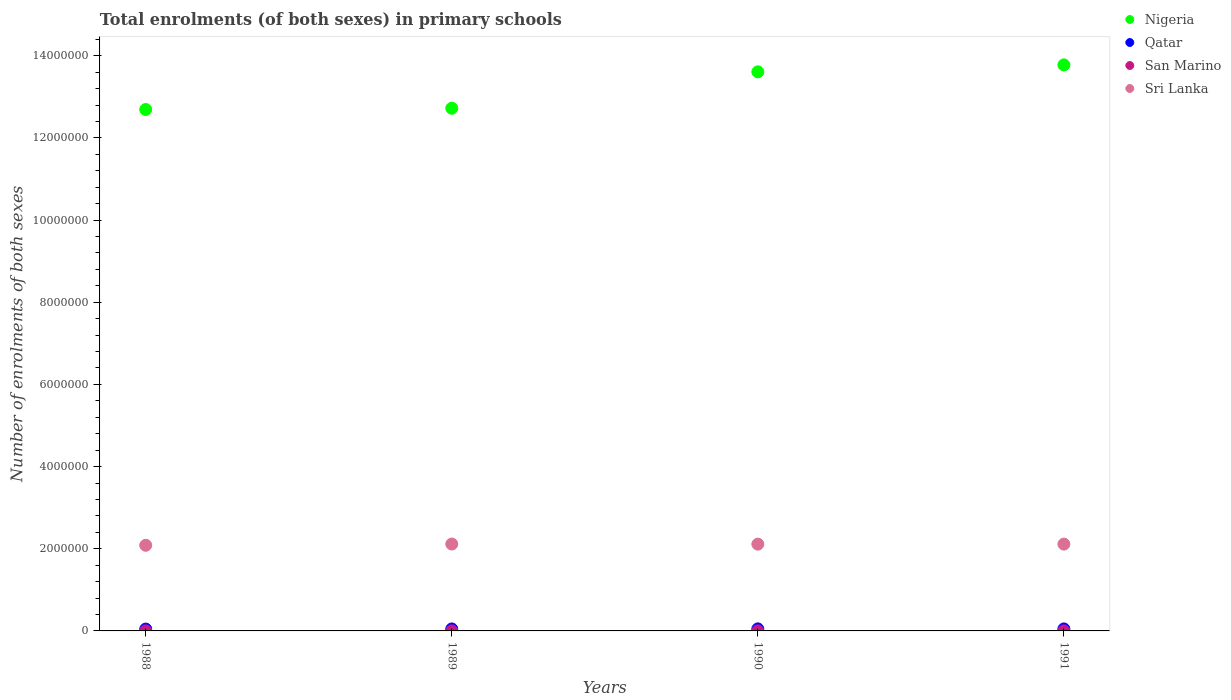How many different coloured dotlines are there?
Your answer should be very brief. 4. Is the number of dotlines equal to the number of legend labels?
Give a very brief answer. Yes. What is the number of enrolments in primary schools in Nigeria in 1988?
Offer a very short reply. 1.27e+07. Across all years, what is the maximum number of enrolments in primary schools in San Marino?
Your response must be concise. 1288. Across all years, what is the minimum number of enrolments in primary schools in Qatar?
Your answer should be very brief. 4.54e+04. What is the total number of enrolments in primary schools in Sri Lanka in the graph?
Make the answer very short. 8.42e+06. What is the difference between the number of enrolments in primary schools in Sri Lanka in 1989 and that in 1990?
Give a very brief answer. 2777. What is the difference between the number of enrolments in primary schools in Qatar in 1991 and the number of enrolments in primary schools in Sri Lanka in 1989?
Your answer should be very brief. -2.07e+06. What is the average number of enrolments in primary schools in Sri Lanka per year?
Give a very brief answer. 2.11e+06. In the year 1989, what is the difference between the number of enrolments in primary schools in Qatar and number of enrolments in primary schools in Sri Lanka?
Give a very brief answer. -2.07e+06. In how many years, is the number of enrolments in primary schools in Sri Lanka greater than 4400000?
Offer a very short reply. 0. What is the ratio of the number of enrolments in primary schools in Qatar in 1989 to that in 1990?
Provide a succinct answer. 0.97. Is the difference between the number of enrolments in primary schools in Qatar in 1988 and 1989 greater than the difference between the number of enrolments in primary schools in Sri Lanka in 1988 and 1989?
Keep it short and to the point. Yes. What is the difference between the highest and the second highest number of enrolments in primary schools in Nigeria?
Offer a terse response. 1.70e+05. What is the difference between the highest and the lowest number of enrolments in primary schools in Nigeria?
Your answer should be very brief. 1.09e+06. Is it the case that in every year, the sum of the number of enrolments in primary schools in Nigeria and number of enrolments in primary schools in Qatar  is greater than the number of enrolments in primary schools in Sri Lanka?
Your answer should be compact. Yes. Is the number of enrolments in primary schools in Nigeria strictly less than the number of enrolments in primary schools in San Marino over the years?
Your answer should be very brief. No. How many dotlines are there?
Your answer should be compact. 4. Does the graph contain grids?
Your answer should be compact. No. What is the title of the graph?
Keep it short and to the point. Total enrolments (of both sexes) in primary schools. Does "Moldova" appear as one of the legend labels in the graph?
Your response must be concise. No. What is the label or title of the X-axis?
Ensure brevity in your answer.  Years. What is the label or title of the Y-axis?
Provide a short and direct response. Number of enrolments of both sexes. What is the Number of enrolments of both sexes in Nigeria in 1988?
Give a very brief answer. 1.27e+07. What is the Number of enrolments of both sexes in Qatar in 1988?
Ensure brevity in your answer.  4.54e+04. What is the Number of enrolments of both sexes of San Marino in 1988?
Ensure brevity in your answer.  1288. What is the Number of enrolments of both sexes of Sri Lanka in 1988?
Your answer should be compact. 2.08e+06. What is the Number of enrolments of both sexes of Nigeria in 1989?
Ensure brevity in your answer.  1.27e+07. What is the Number of enrolments of both sexes in Qatar in 1989?
Ensure brevity in your answer.  4.81e+04. What is the Number of enrolments of both sexes in San Marino in 1989?
Ensure brevity in your answer.  1266. What is the Number of enrolments of both sexes in Sri Lanka in 1989?
Provide a succinct answer. 2.11e+06. What is the Number of enrolments of both sexes in Nigeria in 1990?
Ensure brevity in your answer.  1.36e+07. What is the Number of enrolments of both sexes of Qatar in 1990?
Your response must be concise. 4.97e+04. What is the Number of enrolments of both sexes of San Marino in 1990?
Offer a very short reply. 1227. What is the Number of enrolments of both sexes in Sri Lanka in 1990?
Your answer should be very brief. 2.11e+06. What is the Number of enrolments of both sexes in Nigeria in 1991?
Your response must be concise. 1.38e+07. What is the Number of enrolments of both sexes in Qatar in 1991?
Provide a short and direct response. 4.86e+04. What is the Number of enrolments of both sexes in San Marino in 1991?
Keep it short and to the point. 1212. What is the Number of enrolments of both sexes of Sri Lanka in 1991?
Ensure brevity in your answer.  2.11e+06. Across all years, what is the maximum Number of enrolments of both sexes of Nigeria?
Give a very brief answer. 1.38e+07. Across all years, what is the maximum Number of enrolments of both sexes in Qatar?
Give a very brief answer. 4.97e+04. Across all years, what is the maximum Number of enrolments of both sexes of San Marino?
Make the answer very short. 1288. Across all years, what is the maximum Number of enrolments of both sexes in Sri Lanka?
Ensure brevity in your answer.  2.11e+06. Across all years, what is the minimum Number of enrolments of both sexes of Nigeria?
Offer a very short reply. 1.27e+07. Across all years, what is the minimum Number of enrolments of both sexes in Qatar?
Provide a short and direct response. 4.54e+04. Across all years, what is the minimum Number of enrolments of both sexes in San Marino?
Offer a terse response. 1212. Across all years, what is the minimum Number of enrolments of both sexes in Sri Lanka?
Your answer should be compact. 2.08e+06. What is the total Number of enrolments of both sexes of Nigeria in the graph?
Offer a terse response. 5.28e+07. What is the total Number of enrolments of both sexes of Qatar in the graph?
Make the answer very short. 1.92e+05. What is the total Number of enrolments of both sexes in San Marino in the graph?
Make the answer very short. 4993. What is the total Number of enrolments of both sexes of Sri Lanka in the graph?
Offer a terse response. 8.42e+06. What is the difference between the Number of enrolments of both sexes in Nigeria in 1988 and that in 1989?
Make the answer very short. -3.03e+04. What is the difference between the Number of enrolments of both sexes of Qatar in 1988 and that in 1989?
Ensure brevity in your answer.  -2730. What is the difference between the Number of enrolments of both sexes of San Marino in 1988 and that in 1989?
Keep it short and to the point. 22. What is the difference between the Number of enrolments of both sexes of Sri Lanka in 1988 and that in 1989?
Your answer should be compact. -3.08e+04. What is the difference between the Number of enrolments of both sexes of Nigeria in 1988 and that in 1990?
Provide a succinct answer. -9.16e+05. What is the difference between the Number of enrolments of both sexes in Qatar in 1988 and that in 1990?
Your answer should be very brief. -4290. What is the difference between the Number of enrolments of both sexes of San Marino in 1988 and that in 1990?
Keep it short and to the point. 61. What is the difference between the Number of enrolments of both sexes in Sri Lanka in 1988 and that in 1990?
Your answer should be compact. -2.80e+04. What is the difference between the Number of enrolments of both sexes of Nigeria in 1988 and that in 1991?
Make the answer very short. -1.09e+06. What is the difference between the Number of enrolments of both sexes in Qatar in 1988 and that in 1991?
Offer a very short reply. -3283. What is the difference between the Number of enrolments of both sexes in Sri Lanka in 1988 and that in 1991?
Your response must be concise. -2.87e+04. What is the difference between the Number of enrolments of both sexes in Nigeria in 1989 and that in 1990?
Provide a succinct answer. -8.86e+05. What is the difference between the Number of enrolments of both sexes of Qatar in 1989 and that in 1990?
Offer a terse response. -1560. What is the difference between the Number of enrolments of both sexes in Sri Lanka in 1989 and that in 1990?
Your response must be concise. 2777. What is the difference between the Number of enrolments of both sexes in Nigeria in 1989 and that in 1991?
Provide a short and direct response. -1.06e+06. What is the difference between the Number of enrolments of both sexes in Qatar in 1989 and that in 1991?
Ensure brevity in your answer.  -553. What is the difference between the Number of enrolments of both sexes in Sri Lanka in 1989 and that in 1991?
Your answer should be compact. 2077. What is the difference between the Number of enrolments of both sexes of Nigeria in 1990 and that in 1991?
Provide a short and direct response. -1.70e+05. What is the difference between the Number of enrolments of both sexes in Qatar in 1990 and that in 1991?
Provide a short and direct response. 1007. What is the difference between the Number of enrolments of both sexes of San Marino in 1990 and that in 1991?
Provide a short and direct response. 15. What is the difference between the Number of enrolments of both sexes of Sri Lanka in 1990 and that in 1991?
Your answer should be compact. -700. What is the difference between the Number of enrolments of both sexes of Nigeria in 1988 and the Number of enrolments of both sexes of Qatar in 1989?
Give a very brief answer. 1.26e+07. What is the difference between the Number of enrolments of both sexes in Nigeria in 1988 and the Number of enrolments of both sexes in San Marino in 1989?
Give a very brief answer. 1.27e+07. What is the difference between the Number of enrolments of both sexes of Nigeria in 1988 and the Number of enrolments of both sexes of Sri Lanka in 1989?
Your answer should be compact. 1.06e+07. What is the difference between the Number of enrolments of both sexes of Qatar in 1988 and the Number of enrolments of both sexes of San Marino in 1989?
Provide a short and direct response. 4.41e+04. What is the difference between the Number of enrolments of both sexes of Qatar in 1988 and the Number of enrolments of both sexes of Sri Lanka in 1989?
Ensure brevity in your answer.  -2.07e+06. What is the difference between the Number of enrolments of both sexes of San Marino in 1988 and the Number of enrolments of both sexes of Sri Lanka in 1989?
Make the answer very short. -2.11e+06. What is the difference between the Number of enrolments of both sexes of Nigeria in 1988 and the Number of enrolments of both sexes of Qatar in 1990?
Your response must be concise. 1.26e+07. What is the difference between the Number of enrolments of both sexes of Nigeria in 1988 and the Number of enrolments of both sexes of San Marino in 1990?
Ensure brevity in your answer.  1.27e+07. What is the difference between the Number of enrolments of both sexes of Nigeria in 1988 and the Number of enrolments of both sexes of Sri Lanka in 1990?
Your answer should be compact. 1.06e+07. What is the difference between the Number of enrolments of both sexes in Qatar in 1988 and the Number of enrolments of both sexes in San Marino in 1990?
Ensure brevity in your answer.  4.41e+04. What is the difference between the Number of enrolments of both sexes of Qatar in 1988 and the Number of enrolments of both sexes of Sri Lanka in 1990?
Your answer should be very brief. -2.07e+06. What is the difference between the Number of enrolments of both sexes of San Marino in 1988 and the Number of enrolments of both sexes of Sri Lanka in 1990?
Provide a short and direct response. -2.11e+06. What is the difference between the Number of enrolments of both sexes in Nigeria in 1988 and the Number of enrolments of both sexes in Qatar in 1991?
Make the answer very short. 1.26e+07. What is the difference between the Number of enrolments of both sexes in Nigeria in 1988 and the Number of enrolments of both sexes in San Marino in 1991?
Offer a very short reply. 1.27e+07. What is the difference between the Number of enrolments of both sexes of Nigeria in 1988 and the Number of enrolments of both sexes of Sri Lanka in 1991?
Offer a very short reply. 1.06e+07. What is the difference between the Number of enrolments of both sexes in Qatar in 1988 and the Number of enrolments of both sexes in San Marino in 1991?
Provide a short and direct response. 4.42e+04. What is the difference between the Number of enrolments of both sexes of Qatar in 1988 and the Number of enrolments of both sexes of Sri Lanka in 1991?
Give a very brief answer. -2.07e+06. What is the difference between the Number of enrolments of both sexes in San Marino in 1988 and the Number of enrolments of both sexes in Sri Lanka in 1991?
Provide a succinct answer. -2.11e+06. What is the difference between the Number of enrolments of both sexes in Nigeria in 1989 and the Number of enrolments of both sexes in Qatar in 1990?
Provide a succinct answer. 1.27e+07. What is the difference between the Number of enrolments of both sexes of Nigeria in 1989 and the Number of enrolments of both sexes of San Marino in 1990?
Your answer should be compact. 1.27e+07. What is the difference between the Number of enrolments of both sexes of Nigeria in 1989 and the Number of enrolments of both sexes of Sri Lanka in 1990?
Your answer should be compact. 1.06e+07. What is the difference between the Number of enrolments of both sexes in Qatar in 1989 and the Number of enrolments of both sexes in San Marino in 1990?
Give a very brief answer. 4.69e+04. What is the difference between the Number of enrolments of both sexes of Qatar in 1989 and the Number of enrolments of both sexes of Sri Lanka in 1990?
Your response must be concise. -2.06e+06. What is the difference between the Number of enrolments of both sexes of San Marino in 1989 and the Number of enrolments of both sexes of Sri Lanka in 1990?
Provide a short and direct response. -2.11e+06. What is the difference between the Number of enrolments of both sexes in Nigeria in 1989 and the Number of enrolments of both sexes in Qatar in 1991?
Offer a very short reply. 1.27e+07. What is the difference between the Number of enrolments of both sexes of Nigeria in 1989 and the Number of enrolments of both sexes of San Marino in 1991?
Make the answer very short. 1.27e+07. What is the difference between the Number of enrolments of both sexes in Nigeria in 1989 and the Number of enrolments of both sexes in Sri Lanka in 1991?
Provide a short and direct response. 1.06e+07. What is the difference between the Number of enrolments of both sexes in Qatar in 1989 and the Number of enrolments of both sexes in San Marino in 1991?
Provide a short and direct response. 4.69e+04. What is the difference between the Number of enrolments of both sexes in Qatar in 1989 and the Number of enrolments of both sexes in Sri Lanka in 1991?
Provide a short and direct response. -2.06e+06. What is the difference between the Number of enrolments of both sexes in San Marino in 1989 and the Number of enrolments of both sexes in Sri Lanka in 1991?
Provide a short and direct response. -2.11e+06. What is the difference between the Number of enrolments of both sexes of Nigeria in 1990 and the Number of enrolments of both sexes of Qatar in 1991?
Ensure brevity in your answer.  1.36e+07. What is the difference between the Number of enrolments of both sexes of Nigeria in 1990 and the Number of enrolments of both sexes of San Marino in 1991?
Offer a terse response. 1.36e+07. What is the difference between the Number of enrolments of both sexes in Nigeria in 1990 and the Number of enrolments of both sexes in Sri Lanka in 1991?
Provide a succinct answer. 1.15e+07. What is the difference between the Number of enrolments of both sexes of Qatar in 1990 and the Number of enrolments of both sexes of San Marino in 1991?
Your answer should be compact. 4.84e+04. What is the difference between the Number of enrolments of both sexes of Qatar in 1990 and the Number of enrolments of both sexes of Sri Lanka in 1991?
Offer a very short reply. -2.06e+06. What is the difference between the Number of enrolments of both sexes of San Marino in 1990 and the Number of enrolments of both sexes of Sri Lanka in 1991?
Provide a succinct answer. -2.11e+06. What is the average Number of enrolments of both sexes in Nigeria per year?
Your answer should be very brief. 1.32e+07. What is the average Number of enrolments of both sexes in Qatar per year?
Make the answer very short. 4.79e+04. What is the average Number of enrolments of both sexes of San Marino per year?
Your answer should be very brief. 1248.25. What is the average Number of enrolments of both sexes of Sri Lanka per year?
Provide a succinct answer. 2.11e+06. In the year 1988, what is the difference between the Number of enrolments of both sexes in Nigeria and Number of enrolments of both sexes in Qatar?
Your answer should be very brief. 1.26e+07. In the year 1988, what is the difference between the Number of enrolments of both sexes of Nigeria and Number of enrolments of both sexes of San Marino?
Make the answer very short. 1.27e+07. In the year 1988, what is the difference between the Number of enrolments of both sexes in Nigeria and Number of enrolments of both sexes in Sri Lanka?
Offer a very short reply. 1.06e+07. In the year 1988, what is the difference between the Number of enrolments of both sexes of Qatar and Number of enrolments of both sexes of San Marino?
Keep it short and to the point. 4.41e+04. In the year 1988, what is the difference between the Number of enrolments of both sexes of Qatar and Number of enrolments of both sexes of Sri Lanka?
Offer a very short reply. -2.04e+06. In the year 1988, what is the difference between the Number of enrolments of both sexes of San Marino and Number of enrolments of both sexes of Sri Lanka?
Your response must be concise. -2.08e+06. In the year 1989, what is the difference between the Number of enrolments of both sexes in Nigeria and Number of enrolments of both sexes in Qatar?
Offer a terse response. 1.27e+07. In the year 1989, what is the difference between the Number of enrolments of both sexes in Nigeria and Number of enrolments of both sexes in San Marino?
Ensure brevity in your answer.  1.27e+07. In the year 1989, what is the difference between the Number of enrolments of both sexes in Nigeria and Number of enrolments of both sexes in Sri Lanka?
Keep it short and to the point. 1.06e+07. In the year 1989, what is the difference between the Number of enrolments of both sexes in Qatar and Number of enrolments of both sexes in San Marino?
Give a very brief answer. 4.68e+04. In the year 1989, what is the difference between the Number of enrolments of both sexes in Qatar and Number of enrolments of both sexes in Sri Lanka?
Make the answer very short. -2.07e+06. In the year 1989, what is the difference between the Number of enrolments of both sexes of San Marino and Number of enrolments of both sexes of Sri Lanka?
Your response must be concise. -2.11e+06. In the year 1990, what is the difference between the Number of enrolments of both sexes of Nigeria and Number of enrolments of both sexes of Qatar?
Your response must be concise. 1.36e+07. In the year 1990, what is the difference between the Number of enrolments of both sexes in Nigeria and Number of enrolments of both sexes in San Marino?
Your answer should be very brief. 1.36e+07. In the year 1990, what is the difference between the Number of enrolments of both sexes of Nigeria and Number of enrolments of both sexes of Sri Lanka?
Your answer should be very brief. 1.15e+07. In the year 1990, what is the difference between the Number of enrolments of both sexes in Qatar and Number of enrolments of both sexes in San Marino?
Your response must be concise. 4.84e+04. In the year 1990, what is the difference between the Number of enrolments of both sexes in Qatar and Number of enrolments of both sexes in Sri Lanka?
Your answer should be very brief. -2.06e+06. In the year 1990, what is the difference between the Number of enrolments of both sexes of San Marino and Number of enrolments of both sexes of Sri Lanka?
Offer a terse response. -2.11e+06. In the year 1991, what is the difference between the Number of enrolments of both sexes of Nigeria and Number of enrolments of both sexes of Qatar?
Offer a very short reply. 1.37e+07. In the year 1991, what is the difference between the Number of enrolments of both sexes in Nigeria and Number of enrolments of both sexes in San Marino?
Provide a succinct answer. 1.38e+07. In the year 1991, what is the difference between the Number of enrolments of both sexes in Nigeria and Number of enrolments of both sexes in Sri Lanka?
Offer a very short reply. 1.17e+07. In the year 1991, what is the difference between the Number of enrolments of both sexes in Qatar and Number of enrolments of both sexes in San Marino?
Your response must be concise. 4.74e+04. In the year 1991, what is the difference between the Number of enrolments of both sexes in Qatar and Number of enrolments of both sexes in Sri Lanka?
Provide a short and direct response. -2.06e+06. In the year 1991, what is the difference between the Number of enrolments of both sexes of San Marino and Number of enrolments of both sexes of Sri Lanka?
Your response must be concise. -2.11e+06. What is the ratio of the Number of enrolments of both sexes of Qatar in 1988 to that in 1989?
Your answer should be very brief. 0.94. What is the ratio of the Number of enrolments of both sexes of San Marino in 1988 to that in 1989?
Your answer should be compact. 1.02. What is the ratio of the Number of enrolments of both sexes in Sri Lanka in 1988 to that in 1989?
Your answer should be very brief. 0.99. What is the ratio of the Number of enrolments of both sexes in Nigeria in 1988 to that in 1990?
Ensure brevity in your answer.  0.93. What is the ratio of the Number of enrolments of both sexes in Qatar in 1988 to that in 1990?
Provide a short and direct response. 0.91. What is the ratio of the Number of enrolments of both sexes of San Marino in 1988 to that in 1990?
Keep it short and to the point. 1.05. What is the ratio of the Number of enrolments of both sexes of Sri Lanka in 1988 to that in 1990?
Provide a short and direct response. 0.99. What is the ratio of the Number of enrolments of both sexes of Nigeria in 1988 to that in 1991?
Your response must be concise. 0.92. What is the ratio of the Number of enrolments of both sexes in Qatar in 1988 to that in 1991?
Make the answer very short. 0.93. What is the ratio of the Number of enrolments of both sexes in San Marino in 1988 to that in 1991?
Your answer should be very brief. 1.06. What is the ratio of the Number of enrolments of both sexes in Sri Lanka in 1988 to that in 1991?
Your answer should be very brief. 0.99. What is the ratio of the Number of enrolments of both sexes in Nigeria in 1989 to that in 1990?
Make the answer very short. 0.93. What is the ratio of the Number of enrolments of both sexes of Qatar in 1989 to that in 1990?
Your answer should be very brief. 0.97. What is the ratio of the Number of enrolments of both sexes in San Marino in 1989 to that in 1990?
Your answer should be compact. 1.03. What is the ratio of the Number of enrolments of both sexes in Sri Lanka in 1989 to that in 1990?
Give a very brief answer. 1. What is the ratio of the Number of enrolments of both sexes of Nigeria in 1989 to that in 1991?
Provide a short and direct response. 0.92. What is the ratio of the Number of enrolments of both sexes of Qatar in 1989 to that in 1991?
Offer a very short reply. 0.99. What is the ratio of the Number of enrolments of both sexes in San Marino in 1989 to that in 1991?
Your response must be concise. 1.04. What is the ratio of the Number of enrolments of both sexes of Qatar in 1990 to that in 1991?
Offer a terse response. 1.02. What is the ratio of the Number of enrolments of both sexes of San Marino in 1990 to that in 1991?
Offer a terse response. 1.01. What is the ratio of the Number of enrolments of both sexes of Sri Lanka in 1990 to that in 1991?
Offer a very short reply. 1. What is the difference between the highest and the second highest Number of enrolments of both sexes of Nigeria?
Your answer should be very brief. 1.70e+05. What is the difference between the highest and the second highest Number of enrolments of both sexes in Qatar?
Make the answer very short. 1007. What is the difference between the highest and the second highest Number of enrolments of both sexes of San Marino?
Your response must be concise. 22. What is the difference between the highest and the second highest Number of enrolments of both sexes of Sri Lanka?
Provide a succinct answer. 2077. What is the difference between the highest and the lowest Number of enrolments of both sexes of Nigeria?
Ensure brevity in your answer.  1.09e+06. What is the difference between the highest and the lowest Number of enrolments of both sexes of Qatar?
Provide a succinct answer. 4290. What is the difference between the highest and the lowest Number of enrolments of both sexes in San Marino?
Offer a very short reply. 76. What is the difference between the highest and the lowest Number of enrolments of both sexes of Sri Lanka?
Ensure brevity in your answer.  3.08e+04. 